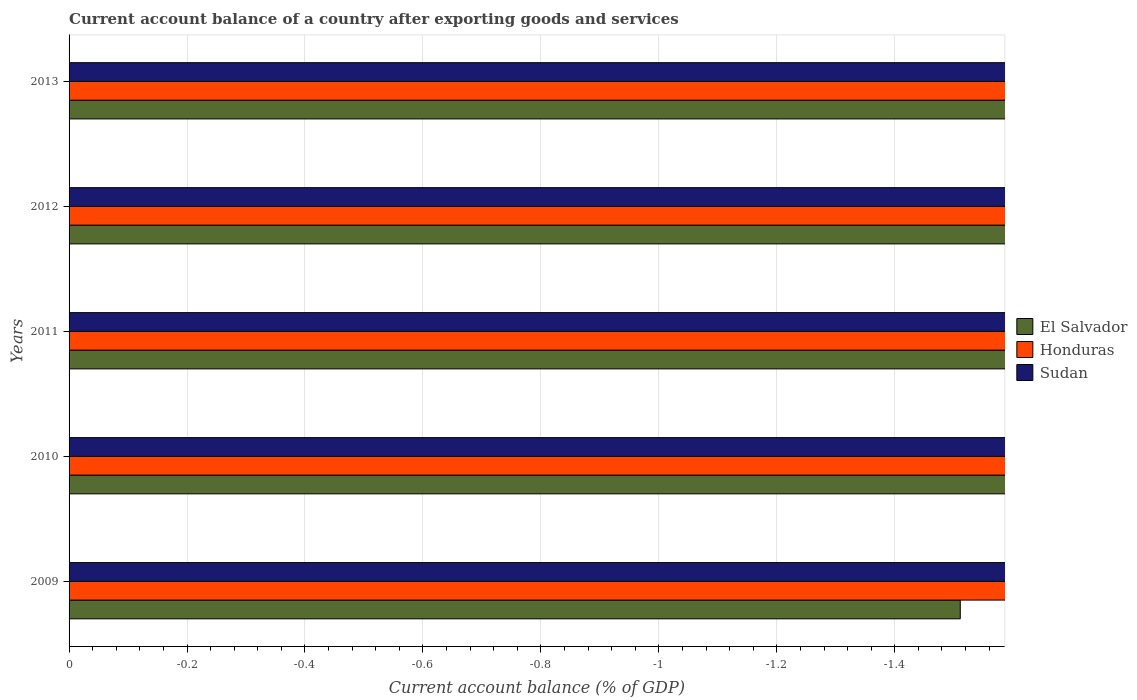Are the number of bars on each tick of the Y-axis equal?
Provide a short and direct response. Yes. How many bars are there on the 2nd tick from the bottom?
Keep it short and to the point. 0. What is the account balance in Honduras in 2010?
Ensure brevity in your answer.  0. Across all years, what is the minimum account balance in Honduras?
Offer a very short reply. 0. What is the total account balance in Honduras in the graph?
Offer a terse response. 0. In how many years, is the account balance in Sudan greater than the average account balance in Sudan taken over all years?
Your answer should be very brief. 0. Is it the case that in every year, the sum of the account balance in Honduras and account balance in Sudan is greater than the account balance in El Salvador?
Your answer should be very brief. No. How many bars are there?
Provide a short and direct response. 0. Are all the bars in the graph horizontal?
Keep it short and to the point. Yes. What is the difference between two consecutive major ticks on the X-axis?
Make the answer very short. 0.2. Does the graph contain grids?
Your response must be concise. Yes. Where does the legend appear in the graph?
Keep it short and to the point. Center right. How many legend labels are there?
Your answer should be very brief. 3. What is the title of the graph?
Keep it short and to the point. Current account balance of a country after exporting goods and services. What is the label or title of the X-axis?
Your answer should be very brief. Current account balance (% of GDP). What is the Current account balance (% of GDP) in El Salvador in 2009?
Provide a short and direct response. 0. What is the Current account balance (% of GDP) in Honduras in 2009?
Ensure brevity in your answer.  0. What is the Current account balance (% of GDP) of Sudan in 2009?
Offer a terse response. 0. What is the Current account balance (% of GDP) in El Salvador in 2010?
Your response must be concise. 0. What is the Current account balance (% of GDP) in Sudan in 2010?
Offer a very short reply. 0. What is the Current account balance (% of GDP) of El Salvador in 2012?
Offer a very short reply. 0. What is the Current account balance (% of GDP) of Honduras in 2012?
Offer a terse response. 0. What is the Current account balance (% of GDP) in Sudan in 2013?
Give a very brief answer. 0. What is the total Current account balance (% of GDP) of Honduras in the graph?
Offer a very short reply. 0. What is the average Current account balance (% of GDP) in El Salvador per year?
Offer a terse response. 0. What is the average Current account balance (% of GDP) in Honduras per year?
Make the answer very short. 0. What is the average Current account balance (% of GDP) in Sudan per year?
Provide a short and direct response. 0. 